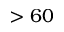<formula> <loc_0><loc_0><loc_500><loc_500>> 6 0</formula> 